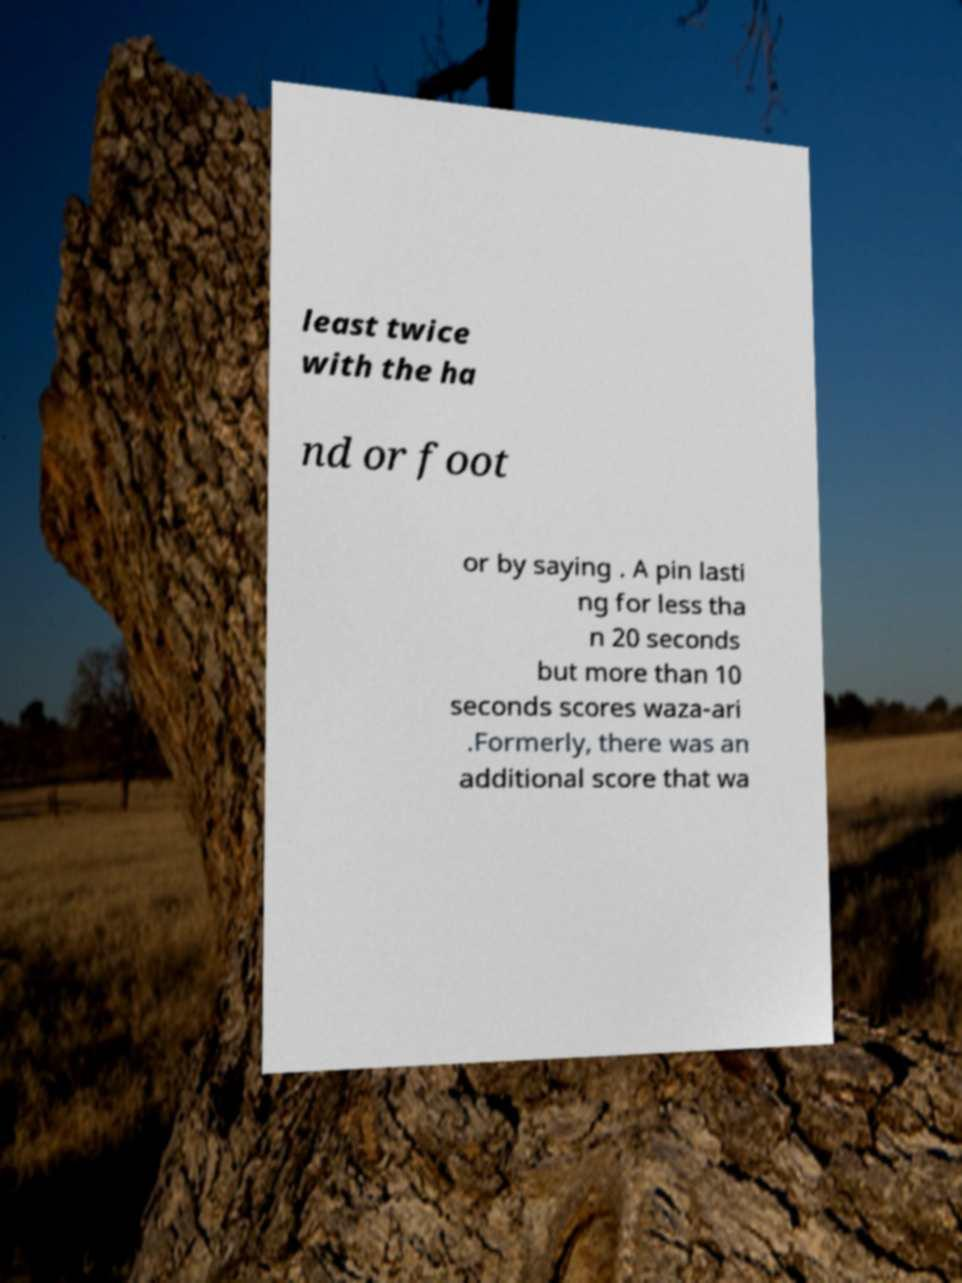Could you extract and type out the text from this image? least twice with the ha nd or foot or by saying . A pin lasti ng for less tha n 20 seconds but more than 10 seconds scores waza-ari .Formerly, there was an additional score that wa 